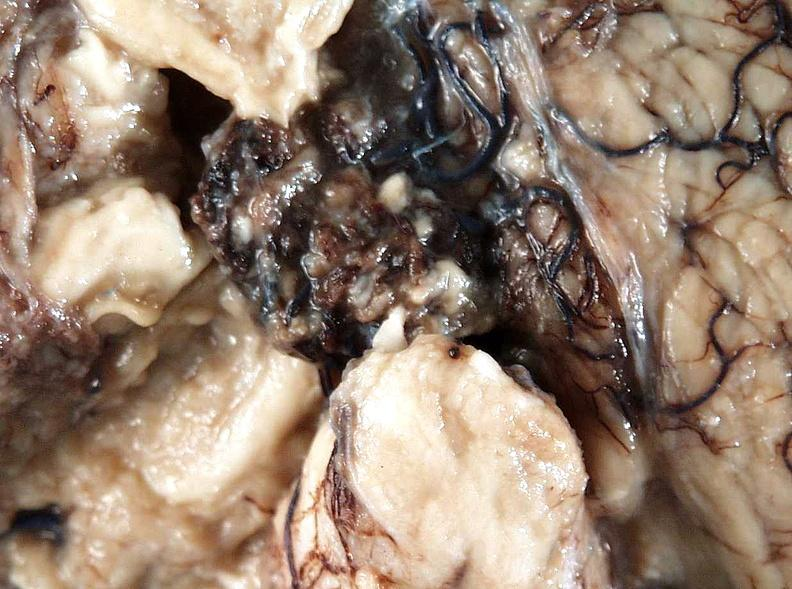does this image show brain, cryptococcal meningitis?
Answer the question using a single word or phrase. Yes 